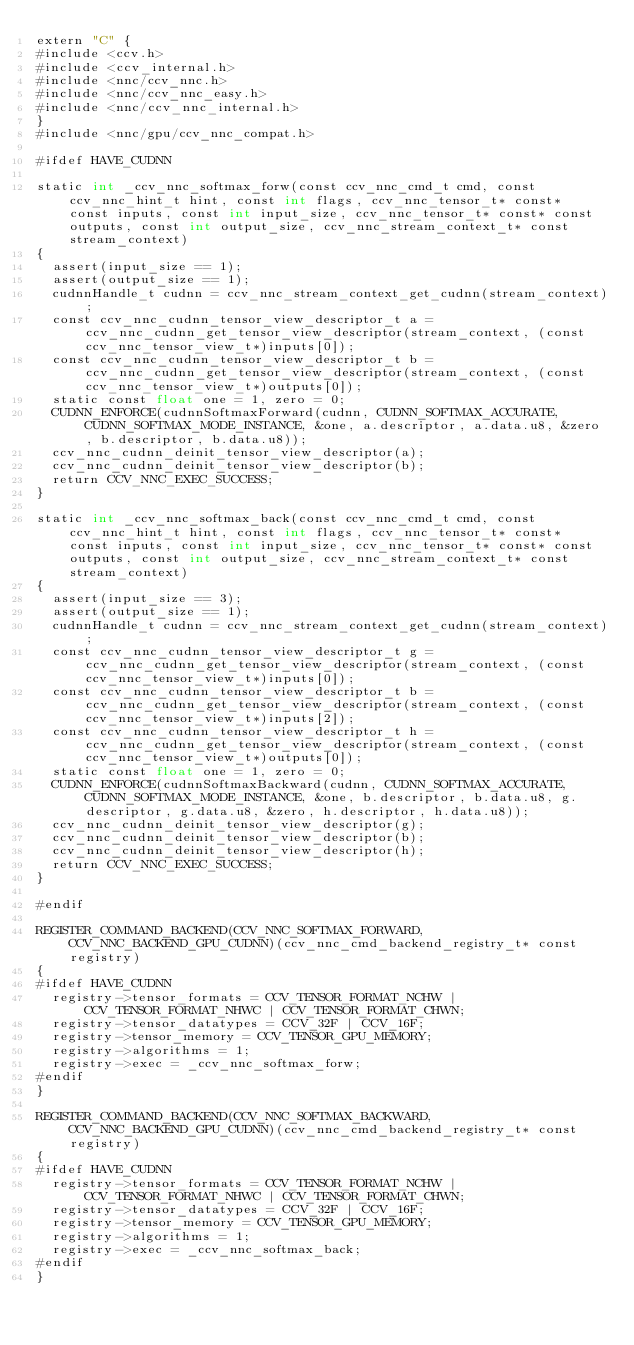Convert code to text. <code><loc_0><loc_0><loc_500><loc_500><_Cuda_>extern "C" {
#include <ccv.h>
#include <ccv_internal.h>
#include <nnc/ccv_nnc.h>
#include <nnc/ccv_nnc_easy.h>
#include <nnc/ccv_nnc_internal.h>
}
#include <nnc/gpu/ccv_nnc_compat.h>

#ifdef HAVE_CUDNN

static int _ccv_nnc_softmax_forw(const ccv_nnc_cmd_t cmd, const ccv_nnc_hint_t hint, const int flags, ccv_nnc_tensor_t* const* const inputs, const int input_size, ccv_nnc_tensor_t* const* const outputs, const int output_size, ccv_nnc_stream_context_t* const stream_context)
{
	assert(input_size == 1);
	assert(output_size == 1);
	cudnnHandle_t cudnn = ccv_nnc_stream_context_get_cudnn(stream_context);
	const ccv_nnc_cudnn_tensor_view_descriptor_t a = ccv_nnc_cudnn_get_tensor_view_descriptor(stream_context, (const ccv_nnc_tensor_view_t*)inputs[0]);
	const ccv_nnc_cudnn_tensor_view_descriptor_t b = ccv_nnc_cudnn_get_tensor_view_descriptor(stream_context, (const ccv_nnc_tensor_view_t*)outputs[0]);
	static const float one = 1, zero = 0;
	CUDNN_ENFORCE(cudnnSoftmaxForward(cudnn, CUDNN_SOFTMAX_ACCURATE, CUDNN_SOFTMAX_MODE_INSTANCE, &one, a.descriptor, a.data.u8, &zero, b.descriptor, b.data.u8));
	ccv_nnc_cudnn_deinit_tensor_view_descriptor(a);
	ccv_nnc_cudnn_deinit_tensor_view_descriptor(b);
	return CCV_NNC_EXEC_SUCCESS;
}

static int _ccv_nnc_softmax_back(const ccv_nnc_cmd_t cmd, const ccv_nnc_hint_t hint, const int flags, ccv_nnc_tensor_t* const* const inputs, const int input_size, ccv_nnc_tensor_t* const* const outputs, const int output_size, ccv_nnc_stream_context_t* const stream_context)
{
	assert(input_size == 3);
	assert(output_size == 1);
	cudnnHandle_t cudnn = ccv_nnc_stream_context_get_cudnn(stream_context);
	const ccv_nnc_cudnn_tensor_view_descriptor_t g = ccv_nnc_cudnn_get_tensor_view_descriptor(stream_context, (const ccv_nnc_tensor_view_t*)inputs[0]);
	const ccv_nnc_cudnn_tensor_view_descriptor_t b = ccv_nnc_cudnn_get_tensor_view_descriptor(stream_context, (const ccv_nnc_tensor_view_t*)inputs[2]);
	const ccv_nnc_cudnn_tensor_view_descriptor_t h = ccv_nnc_cudnn_get_tensor_view_descriptor(stream_context, (const ccv_nnc_tensor_view_t*)outputs[0]);
	static const float one = 1, zero = 0;
	CUDNN_ENFORCE(cudnnSoftmaxBackward(cudnn, CUDNN_SOFTMAX_ACCURATE, CUDNN_SOFTMAX_MODE_INSTANCE, &one, b.descriptor, b.data.u8, g.descriptor, g.data.u8, &zero, h.descriptor, h.data.u8));
	ccv_nnc_cudnn_deinit_tensor_view_descriptor(g);
	ccv_nnc_cudnn_deinit_tensor_view_descriptor(b);
	ccv_nnc_cudnn_deinit_tensor_view_descriptor(h);
	return CCV_NNC_EXEC_SUCCESS;
}

#endif

REGISTER_COMMAND_BACKEND(CCV_NNC_SOFTMAX_FORWARD, CCV_NNC_BACKEND_GPU_CUDNN)(ccv_nnc_cmd_backend_registry_t* const registry)
{
#ifdef HAVE_CUDNN
	registry->tensor_formats = CCV_TENSOR_FORMAT_NCHW | CCV_TENSOR_FORMAT_NHWC | CCV_TENSOR_FORMAT_CHWN;
	registry->tensor_datatypes = CCV_32F | CCV_16F;
	registry->tensor_memory = CCV_TENSOR_GPU_MEMORY;
	registry->algorithms = 1;
	registry->exec = _ccv_nnc_softmax_forw;
#endif
}

REGISTER_COMMAND_BACKEND(CCV_NNC_SOFTMAX_BACKWARD, CCV_NNC_BACKEND_GPU_CUDNN)(ccv_nnc_cmd_backend_registry_t* const registry)
{
#ifdef HAVE_CUDNN
	registry->tensor_formats = CCV_TENSOR_FORMAT_NCHW | CCV_TENSOR_FORMAT_NHWC | CCV_TENSOR_FORMAT_CHWN;
	registry->tensor_datatypes = CCV_32F | CCV_16F;
	registry->tensor_memory = CCV_TENSOR_GPU_MEMORY;
	registry->algorithms = 1;
	registry->exec = _ccv_nnc_softmax_back;
#endif
}
</code> 